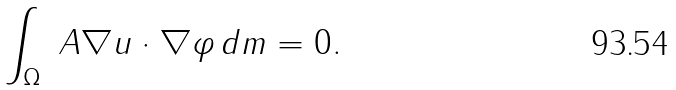<formula> <loc_0><loc_0><loc_500><loc_500>\int _ { \Omega } \ A \nabla u \cdot \nabla \varphi \, d m = 0 .</formula> 